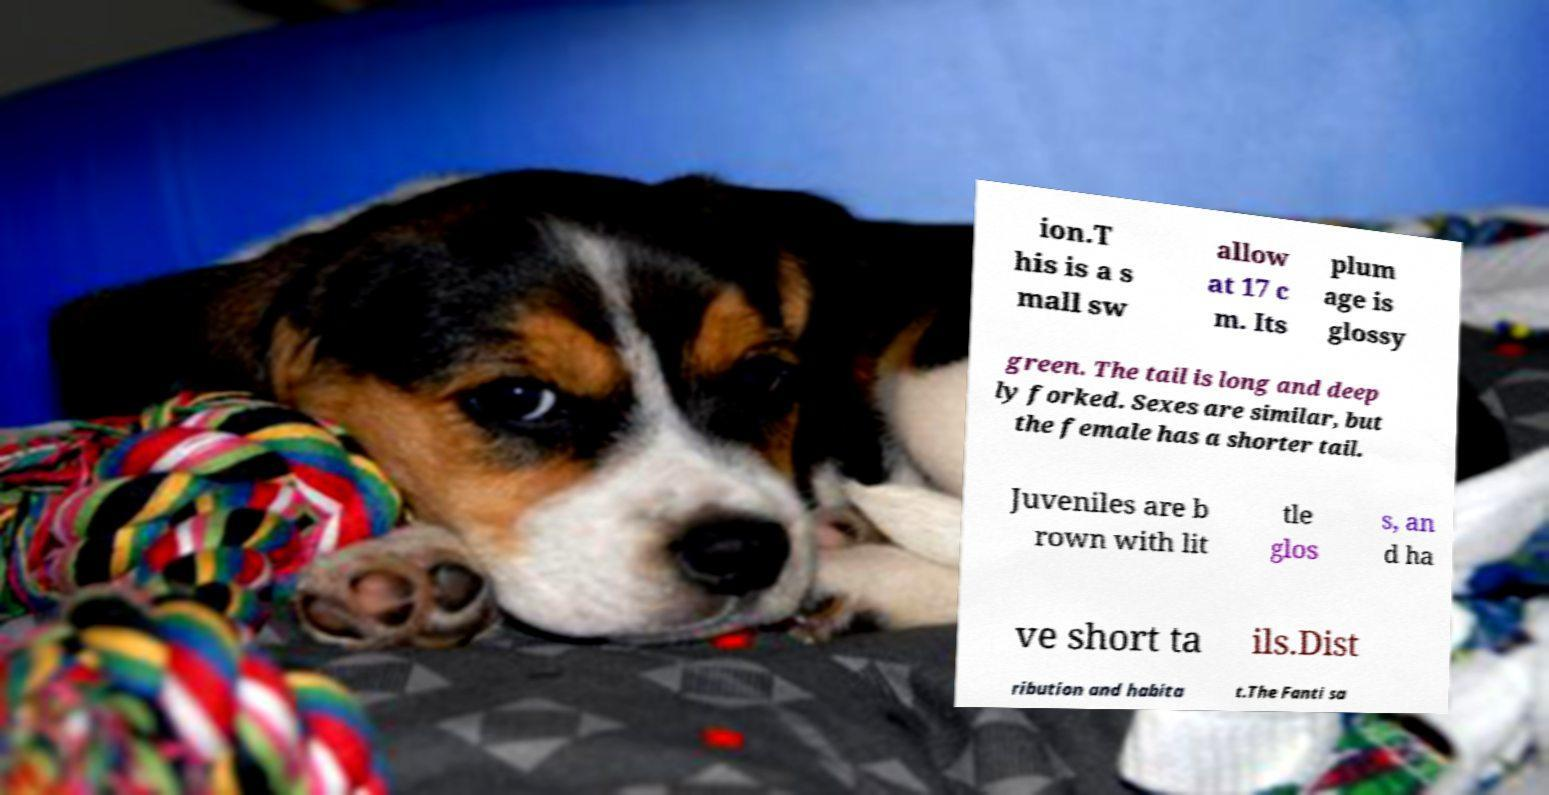For documentation purposes, I need the text within this image transcribed. Could you provide that? ion.T his is a s mall sw allow at 17 c m. Its plum age is glossy green. The tail is long and deep ly forked. Sexes are similar, but the female has a shorter tail. Juveniles are b rown with lit tle glos s, an d ha ve short ta ils.Dist ribution and habita t.The Fanti sa 